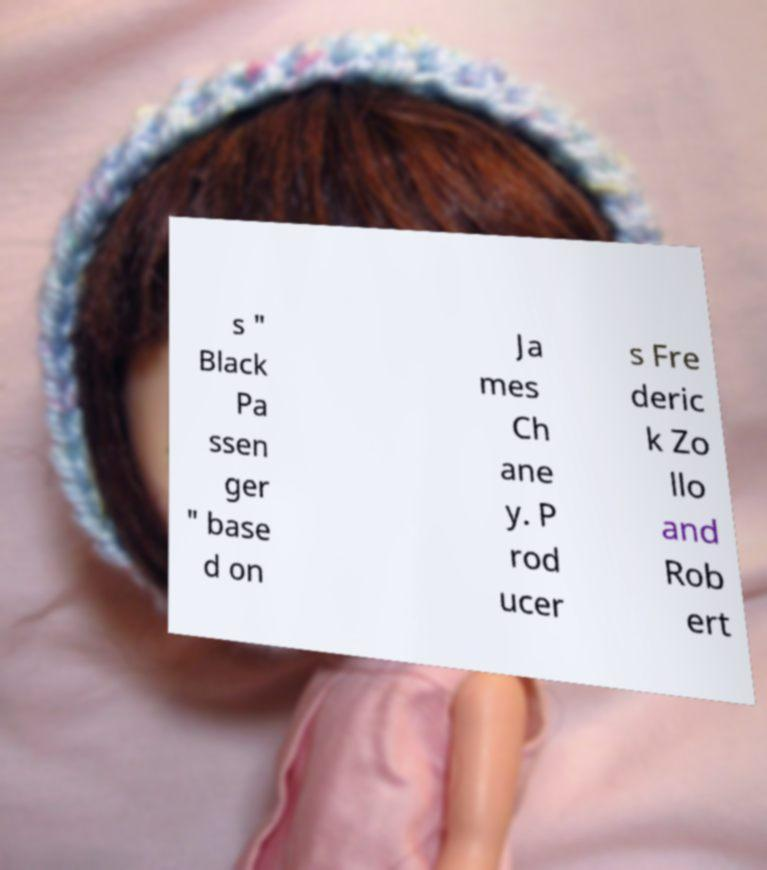There's text embedded in this image that I need extracted. Can you transcribe it verbatim? s " Black Pa ssen ger " base d on Ja mes Ch ane y. P rod ucer s Fre deric k Zo llo and Rob ert 